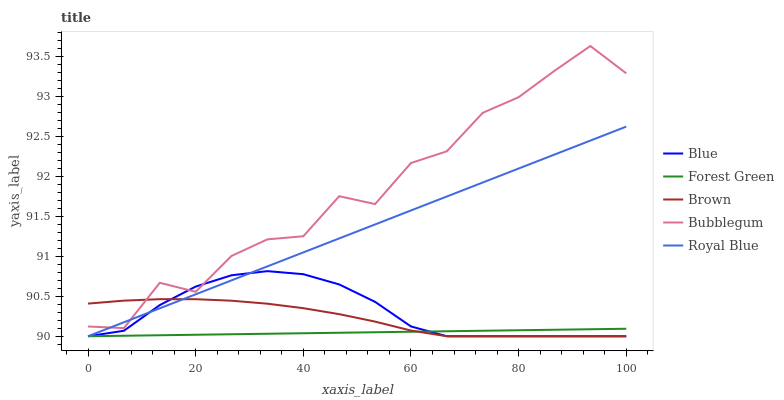Does Brown have the minimum area under the curve?
Answer yes or no. No. Does Brown have the maximum area under the curve?
Answer yes or no. No. Is Brown the smoothest?
Answer yes or no. No. Is Brown the roughest?
Answer yes or no. No. Does Bubblegum have the lowest value?
Answer yes or no. No. Does Brown have the highest value?
Answer yes or no. No. Is Forest Green less than Bubblegum?
Answer yes or no. Yes. Is Bubblegum greater than Forest Green?
Answer yes or no. Yes. Does Forest Green intersect Bubblegum?
Answer yes or no. No. 